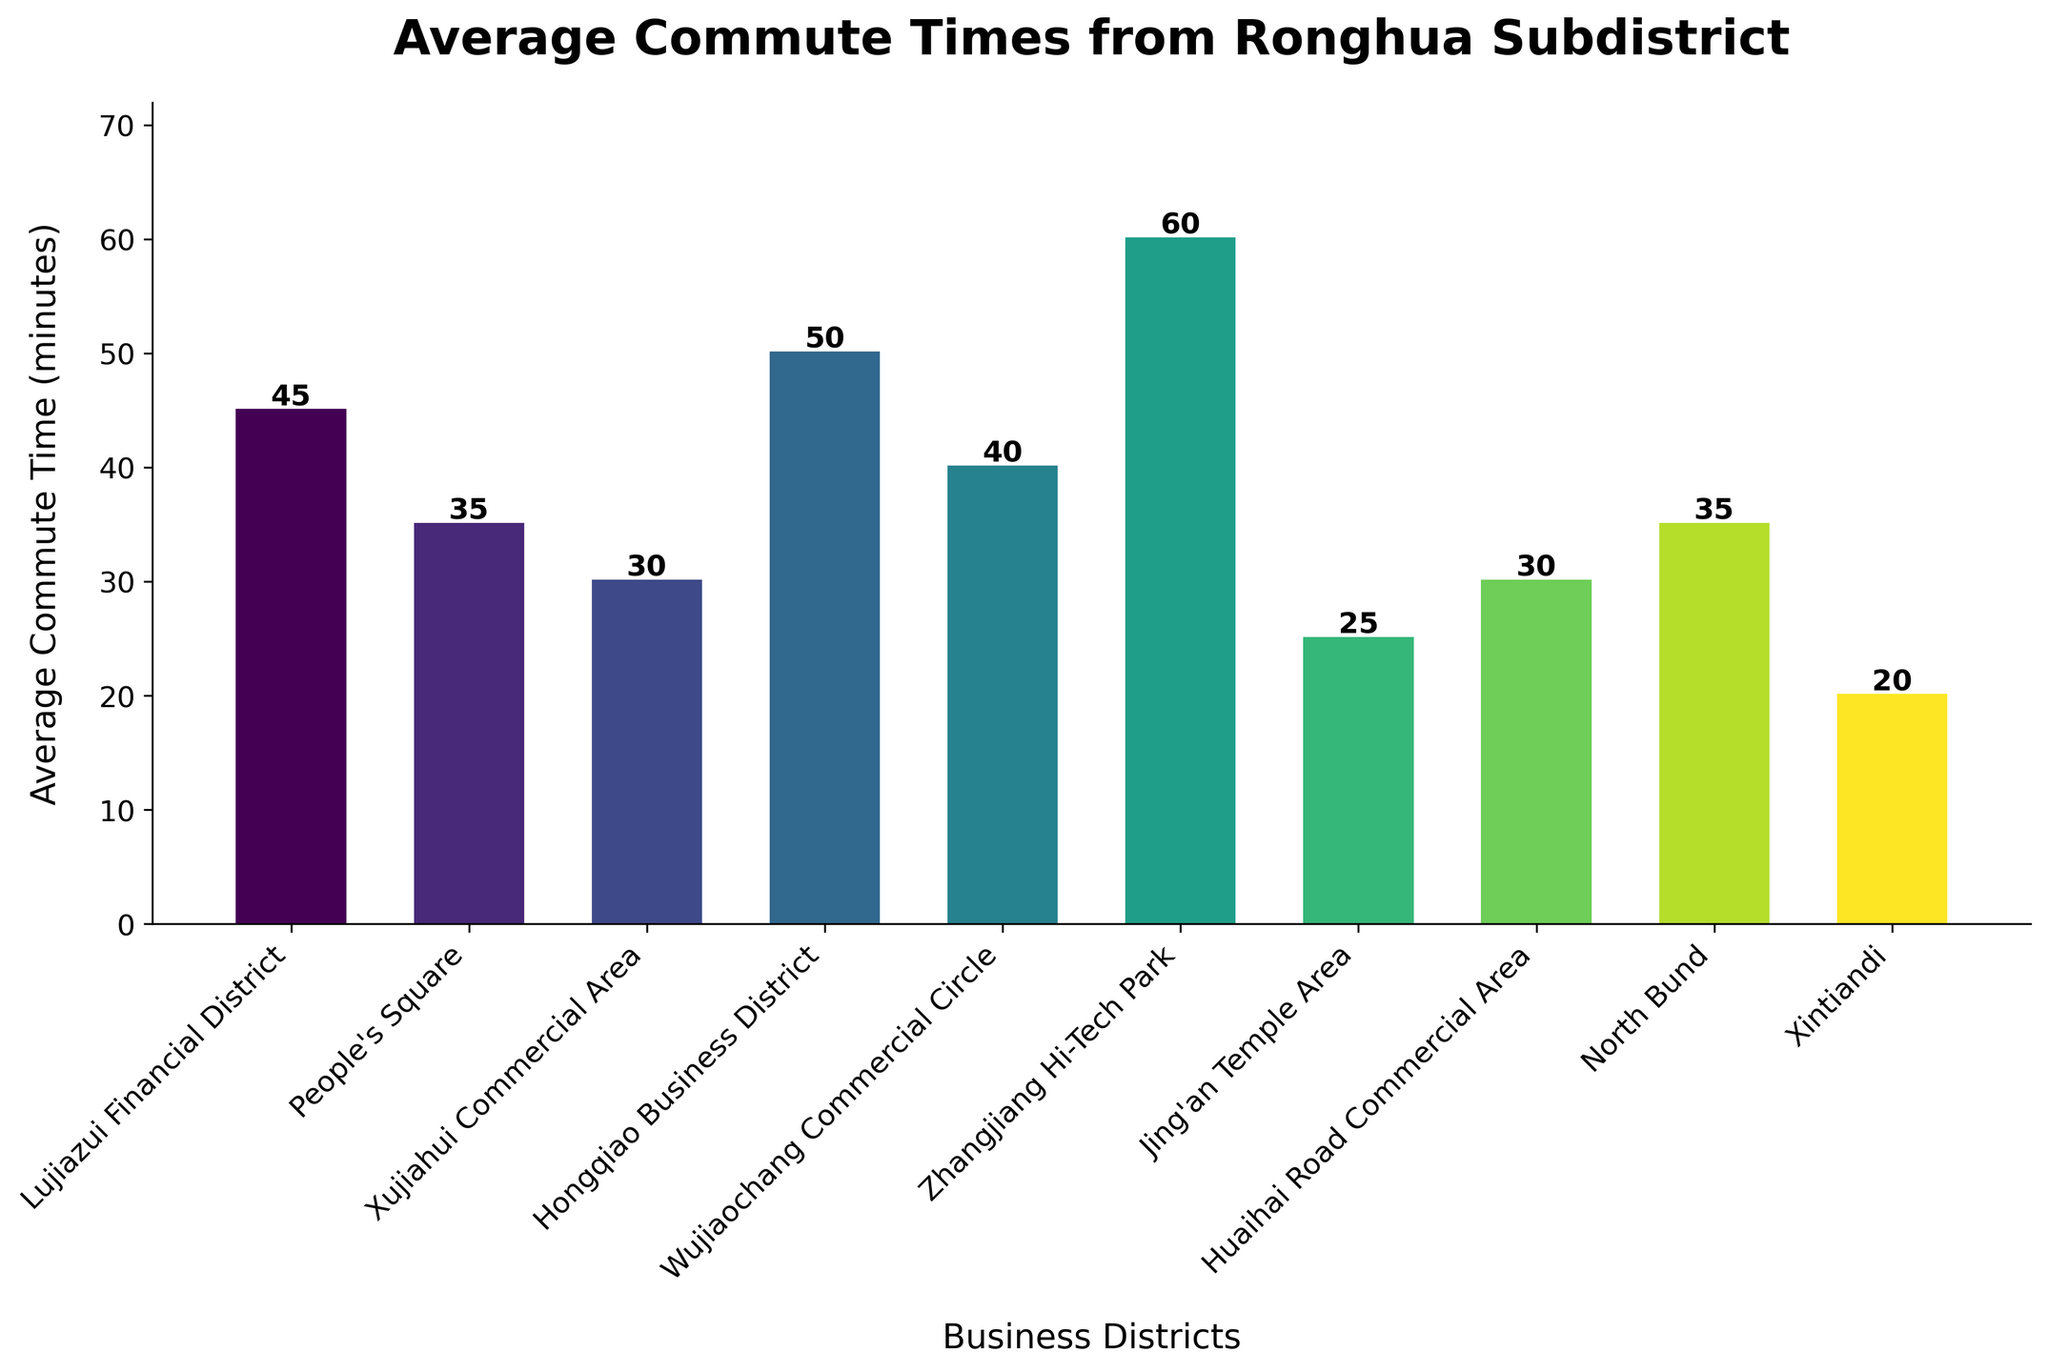Which business district has the shortest average commute time from Ronghua Subdistrict? By looking at the height of the bars, the shortest bar corresponds to Xintiandi.
Answer: Xintiandi Which business district has the longest average commute time from Ronghua Subdistrict? By looking at the height of the bars, the tallest bar corresponds to Zhangjiang Hi-Tech Park.
Answer: Zhangjiang Hi-Tech Park What is the average commute time for People's Square and North Bund combined? The commute times for People's Square and North Bund are 35 minutes each. Summing them up gives 35 + 35 = 70 minutes, and the average is 70 / 2 = 35 minutes.
Answer: 35 minutes How much longer is the commute to Zhangjiang Hi-Tech Park compared to Xintiandi? The commute time for Zhangjiang Hi-Tech Park is 60 minutes, and for Xintiandi, it is 20 minutes. The difference is 60 - 20 = 40 minutes.
Answer: 40 minutes Which districts have a commute time of 30 minutes? By checking the heights of the bars, the districts with commute times of 30 minutes are Xujiahui Commercial Area and Huaihai Road Commercial Area.
Answer: Xujiahui Commercial Area, Huaihai Road Commercial Area Is the commute time to Hongqiao Business District greater than to Wujiaochang Commercial Circle? The commute time to Hongqiao Business District is 50 minutes, and to Wujiaochang Commercial Circle, it is 40 minutes, so 50 is greater than 40.
Answer: Yes What is the total of all the average commute times? Summing all the average commute times: 45 + 35 + 30 + 50 + 40 + 60 + 25 + 30 + 35 + 20 = 370 minutes.
Answer: 370 minutes What is the average commute time for all ten business districts? First find the total of all commute times, which is 370 minutes. There are 10 districts, so the average is 370 / 10 = 37 minutes.
Answer: 37 minutes Is the commute time to People's Square equal to the commute time to North Bund? The commute time to People's Square is 35 minutes, and to North Bund, it is also 35 minutes.
Answer: Yes 